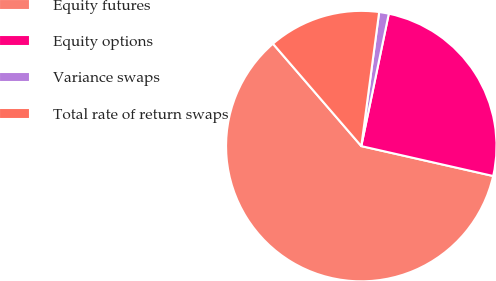<chart> <loc_0><loc_0><loc_500><loc_500><pie_chart><fcel>Equity futures<fcel>Equity options<fcel>Variance swaps<fcel>Total rate of return swaps<nl><fcel>60.12%<fcel>25.29%<fcel>1.15%<fcel>13.44%<nl></chart> 